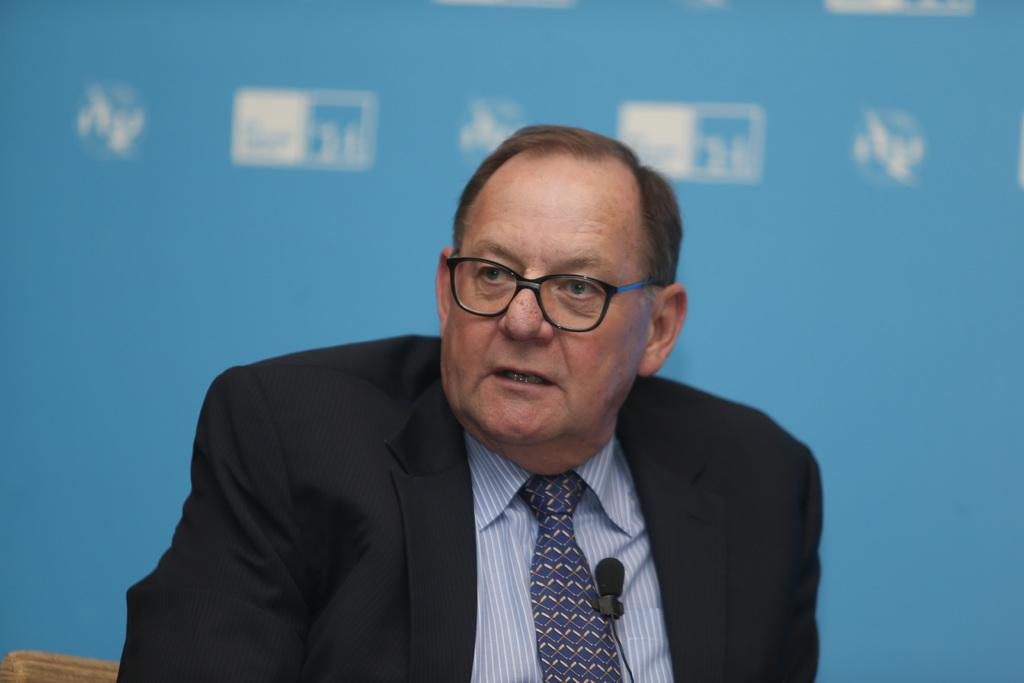What is the person in the image wearing? The person is wearing a dress with blue, white, and black colors. What object can be seen in the image that is typically used for speaking or singing? There is a microphone (mic) in the image. What colors are present in the background of the image? The background of the image has blue and white colors. How many clams are visible on the person's dress in the image? There are no clams visible on the person's dress in the image. What type of organization is represented by the pig in the image? There is no pig present in the image, so it is not possible to determine any representation of an organization. 